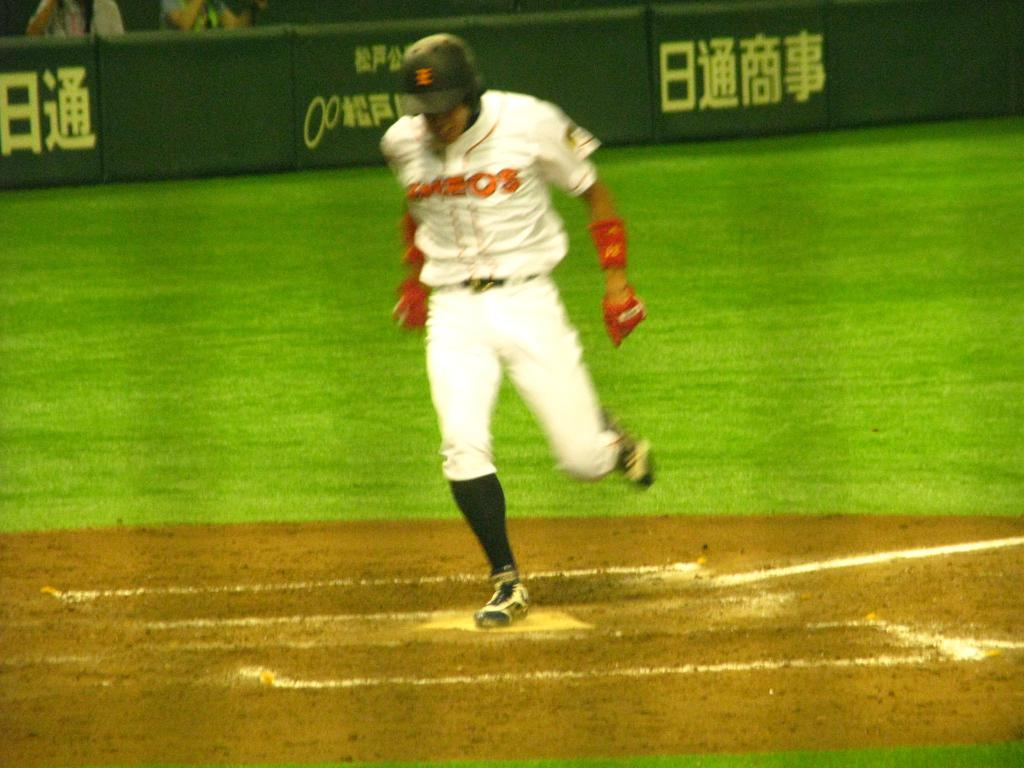<image>
Provide a brief description of the given image. A Japanes baseball player runs on the field in front of advertising hoardings with Japanese writing. 